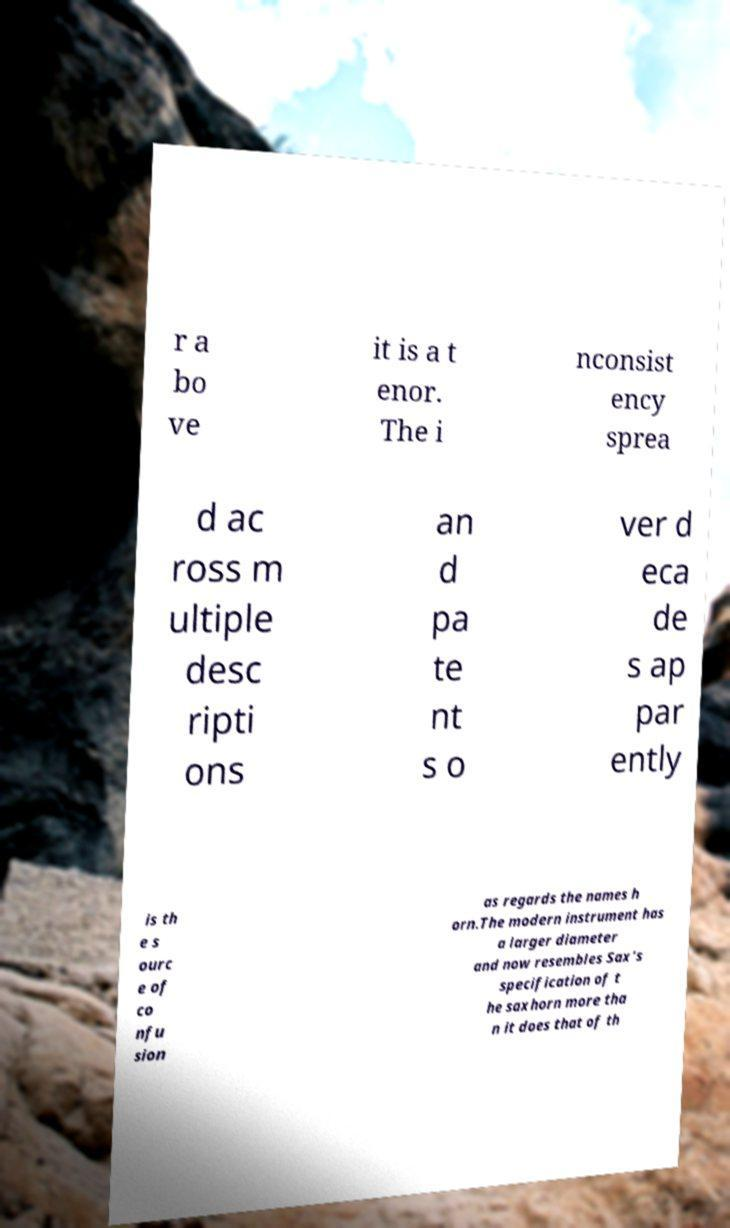Could you assist in decoding the text presented in this image and type it out clearly? r a bo ve it is a t enor. The i nconsist ency sprea d ac ross m ultiple desc ripti ons an d pa te nt s o ver d eca de s ap par ently is th e s ourc e of co nfu sion as regards the names h orn.The modern instrument has a larger diameter and now resembles Sax's specification of t he saxhorn more tha n it does that of th 